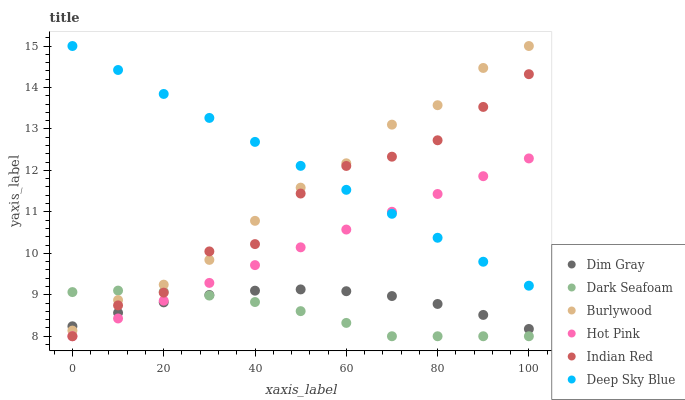Does Dark Seafoam have the minimum area under the curve?
Answer yes or no. Yes. Does Deep Sky Blue have the maximum area under the curve?
Answer yes or no. Yes. Does Indian Red have the minimum area under the curve?
Answer yes or no. No. Does Indian Red have the maximum area under the curve?
Answer yes or no. No. Is Hot Pink the smoothest?
Answer yes or no. Yes. Is Indian Red the roughest?
Answer yes or no. Yes. Is Burlywood the smoothest?
Answer yes or no. No. Is Burlywood the roughest?
Answer yes or no. No. Does Indian Red have the lowest value?
Answer yes or no. Yes. Does Burlywood have the lowest value?
Answer yes or no. No. Does Deep Sky Blue have the highest value?
Answer yes or no. Yes. Does Indian Red have the highest value?
Answer yes or no. No. Is Dim Gray less than Deep Sky Blue?
Answer yes or no. Yes. Is Deep Sky Blue greater than Dark Seafoam?
Answer yes or no. Yes. Does Dim Gray intersect Indian Red?
Answer yes or no. Yes. Is Dim Gray less than Indian Red?
Answer yes or no. No. Is Dim Gray greater than Indian Red?
Answer yes or no. No. Does Dim Gray intersect Deep Sky Blue?
Answer yes or no. No. 